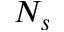<formula> <loc_0><loc_0><loc_500><loc_500>N _ { s }</formula> 